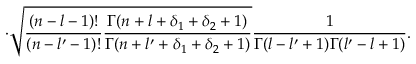Convert formula to latex. <formula><loc_0><loc_0><loc_500><loc_500>\cdot \sqrt { \frac { ( n - l - 1 ) ! } { ( n - l ^ { \prime } - 1 ) ! } \frac { \Gamma ( n + l + \delta _ { 1 } + \delta _ { 2 } + 1 ) } { \Gamma ( n + l ^ { \prime } + \delta _ { 1 } + \delta _ { 2 } + 1 ) } } \frac { 1 } { \Gamma ( l - l ^ { \prime } + 1 ) \Gamma ( l ^ { \prime } - l + 1 ) } .</formula> 